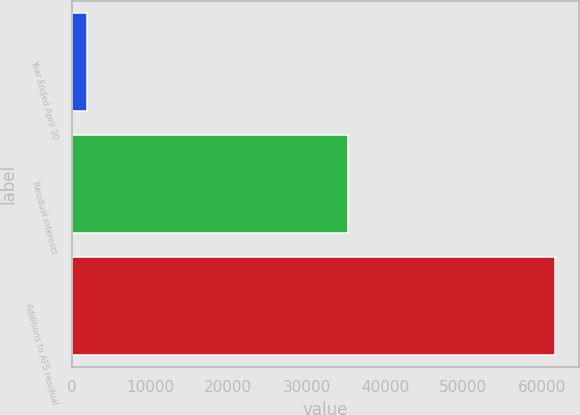<chart> <loc_0><loc_0><loc_500><loc_500><bar_chart><fcel>Year Ended April 30<fcel>Residual interests<fcel>Additions to AFS residual<nl><fcel>2006<fcel>35274<fcel>61651<nl></chart> 